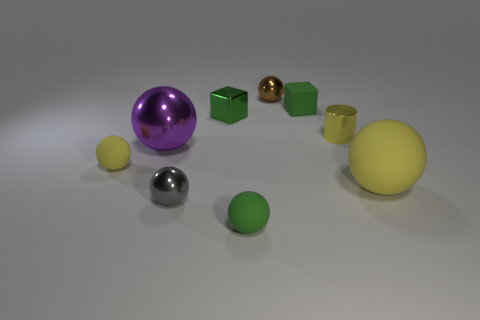Does the yellow matte thing to the left of the green matte cube have the same shape as the matte object that is behind the tiny cylinder?
Make the answer very short. No. What number of objects are small matte spheres or things that are behind the small yellow sphere?
Offer a very short reply. 7. How many other things are there of the same shape as the small green shiny thing?
Your answer should be compact. 1. Does the yellow ball to the right of the big purple metallic object have the same material as the green sphere?
Your response must be concise. Yes. What number of objects are tiny yellow cylinders or blue shiny balls?
Offer a very short reply. 1. The purple shiny thing that is the same shape as the small gray object is what size?
Give a very brief answer. Large. What is the size of the brown metallic object?
Ensure brevity in your answer.  Small. Are there more tiny metallic objects that are to the left of the metal block than small gray metallic cylinders?
Offer a terse response. Yes. There is a rubber sphere that is left of the purple sphere; does it have the same color as the large ball right of the gray metal thing?
Your response must be concise. Yes. The yellow sphere that is right of the green matte thing behind the big object in front of the tiny yellow rubber sphere is made of what material?
Offer a terse response. Rubber. 